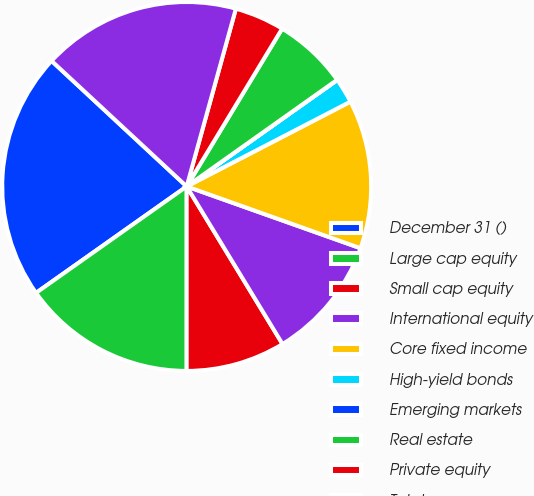Convert chart. <chart><loc_0><loc_0><loc_500><loc_500><pie_chart><fcel>December 31 ()<fcel>Large cap equity<fcel>Small cap equity<fcel>International equity<fcel>Core fixed income<fcel>High-yield bonds<fcel>Emerging markets<fcel>Real estate<fcel>Private equity<fcel>Total<nl><fcel>21.71%<fcel>15.21%<fcel>8.7%<fcel>10.87%<fcel>13.04%<fcel>2.19%<fcel>0.02%<fcel>6.53%<fcel>4.36%<fcel>17.38%<nl></chart> 